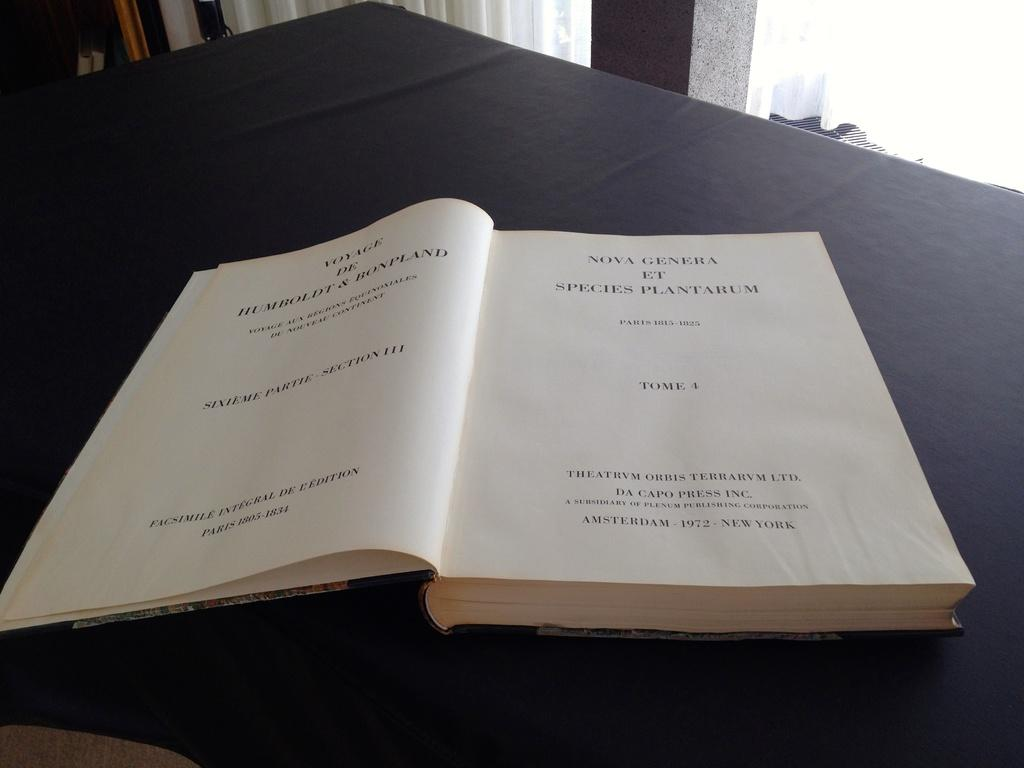Provide a one-sentence caption for the provided image. Nova Genera Et species plantarum chapter book that is open. 